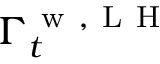Convert formula to latex. <formula><loc_0><loc_0><loc_500><loc_500>\Gamma _ { t } ^ { w , L H }</formula> 